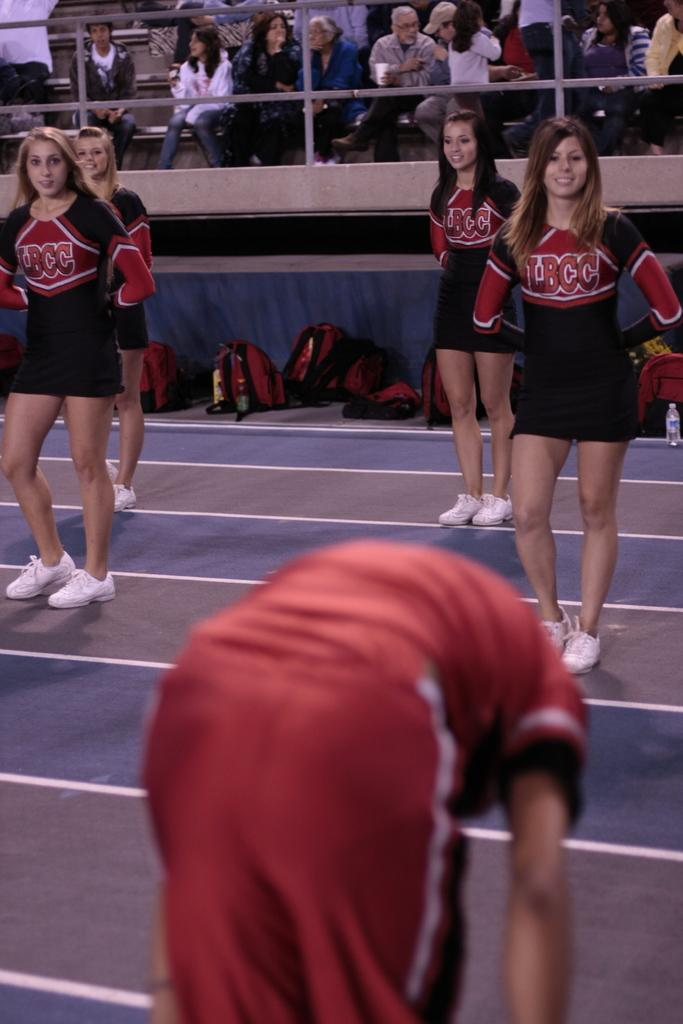Provide a one-sentence caption for the provided image. guy in red bent over in front of 4 lbcc cheerleaders and small crowd in the stands. 